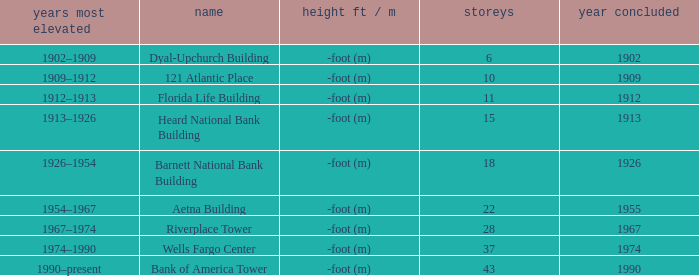How tall is the florida life building, completed before 1990? -foot (m). 